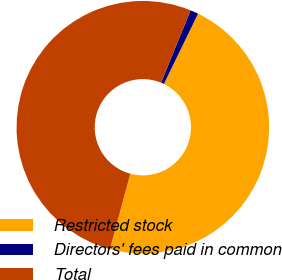<chart> <loc_0><loc_0><loc_500><loc_500><pie_chart><fcel>Restricted stock<fcel>Directors' fees paid in common<fcel>Total<nl><fcel>47.0%<fcel>1.03%<fcel>51.97%<nl></chart> 